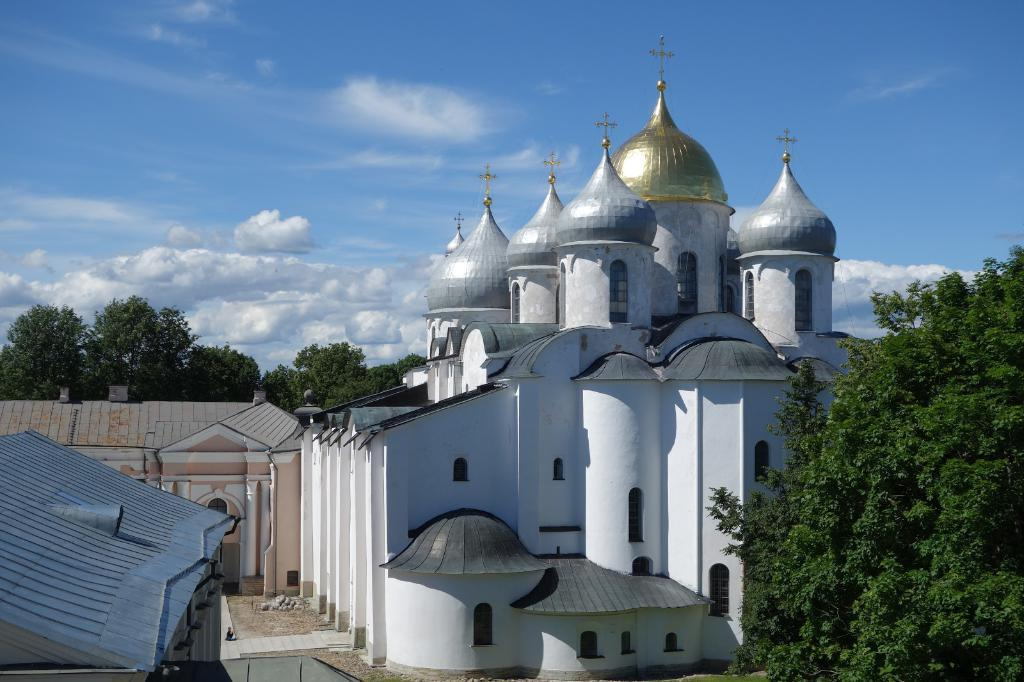What can be seen in the background of the image? There is a sky visible in the image. What is present in the sky? Clouds are present in the sky. Where is the mailbox located in the image? There is no mailbox present in the image. What type of crack is visible on the clouds in the image? There are no cracks visible on the clouds in the image. 